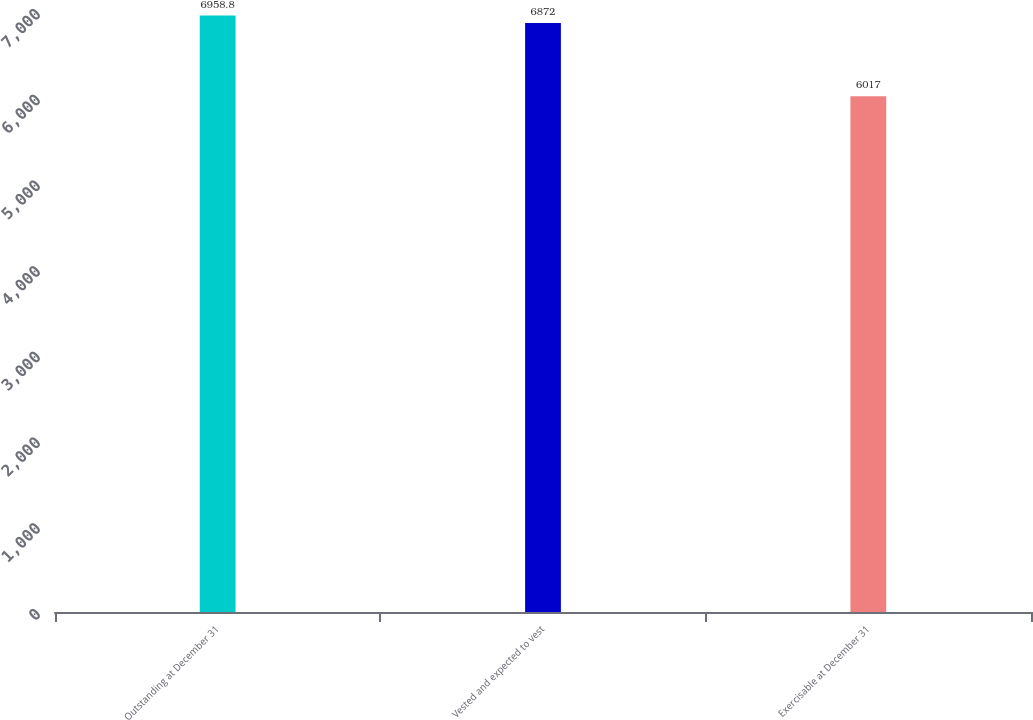Convert chart to OTSL. <chart><loc_0><loc_0><loc_500><loc_500><bar_chart><fcel>Outstanding at December 31<fcel>Vested and expected to vest<fcel>Exercisable at December 31<nl><fcel>6958.8<fcel>6872<fcel>6017<nl></chart> 